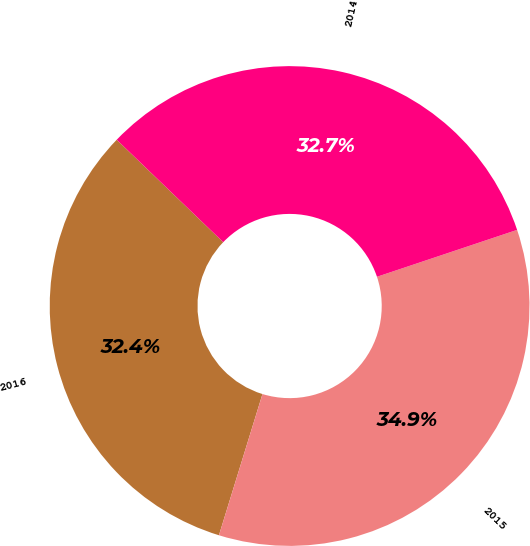<chart> <loc_0><loc_0><loc_500><loc_500><pie_chart><fcel>2016<fcel>2015<fcel>2014<nl><fcel>32.43%<fcel>34.9%<fcel>32.67%<nl></chart> 